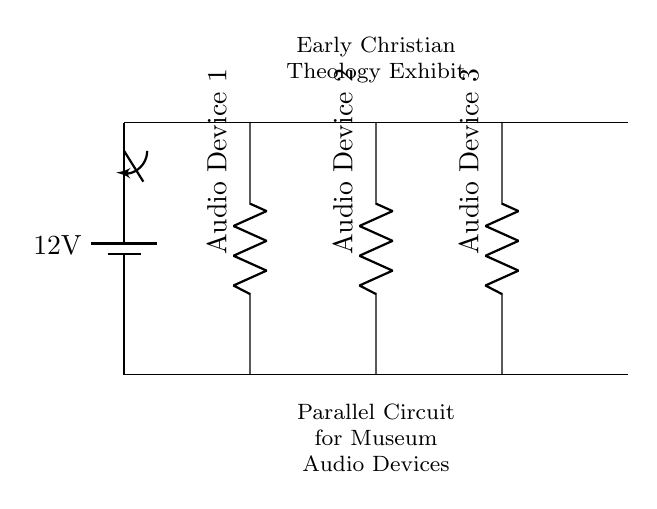What is the total voltage in this circuit? The total voltage in the circuit is determined by the battery, which is labeled as 12 volts. This is the only source of voltage in the circuit, so the total is 12 volts.
Answer: 12 volts How many audio devices are connected in this circuit? By counting the components labeled as "Audio Device 1," "Audio Device 2," and "Audio Device 3," we see there are three audio devices connected in parallel.
Answer: Three audio devices What type of circuit is depicted in the diagram? The diagram shows a parallel circuit, characterized by multiple paths for current to flow through each audio device. This is evident because each device is connected directly to the voltage source without being in series with one another.
Answer: Parallel circuit What is the purpose of the switch in the circuit? The switch controls the flow of electricity in the circuit. It can either complete the circuit (allowing current to pass to the audio devices) or interrupt it (stopping the flow of electricity), effectively turning the audio devices on or off.
Answer: To control the power What would happen if one audio device fails in this circuit? If one audio device fails (like a broken wire or malfunction), the other devices would continue to function normally. This is a characteristic advantage of parallel circuits, allowing independent operation of components.
Answer: Other devices still work What is the current path when the switch is closed? When the switch is closed, the circuit completes and current flows from the battery through the switch to each audio device. Each device receives the same voltage, but the current divided among them depends on their resistance values.
Answer: Current flows through all devices 